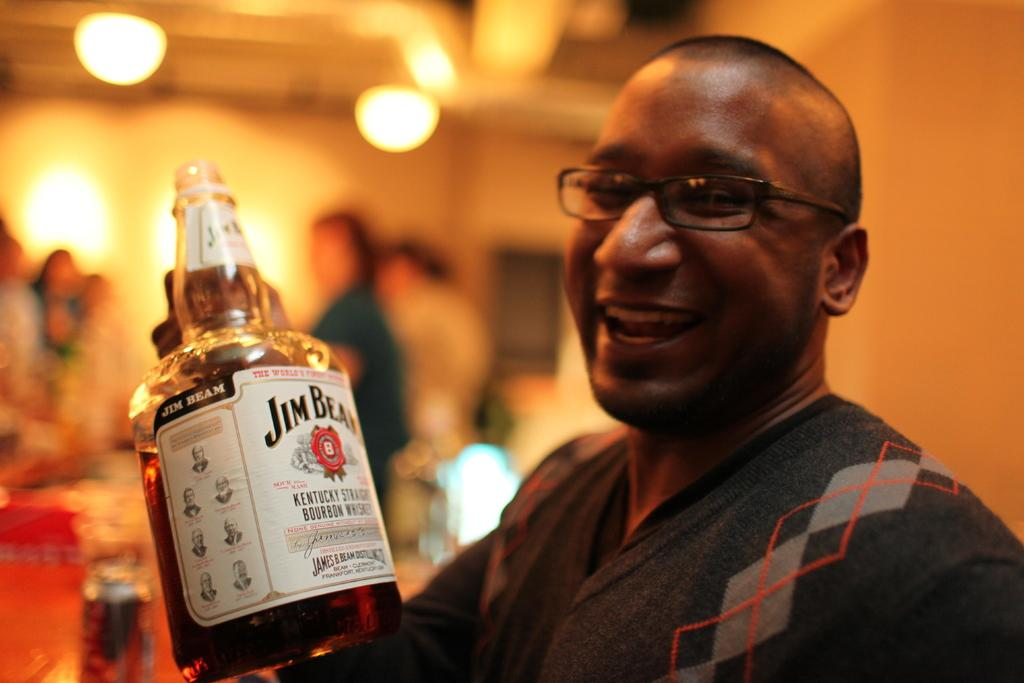Who is the main subject in the image? There is a guy in the image. What is the guy wearing? The guy is wearing a black jacket. What is the guy holding in his hand? The guy is holding a bottle in his hand. What type of doctor is the guy in the image pretending to be? The image does not show the guy pretending to be a doctor, nor is there any indication of a medical profession. 